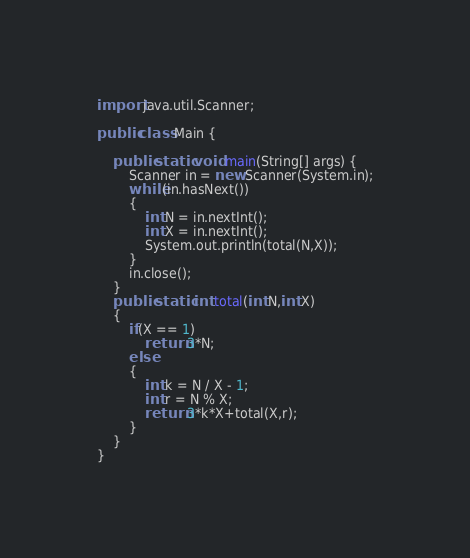<code> <loc_0><loc_0><loc_500><loc_500><_Java_>import java.util.Scanner;

public class Main {

	public static void main(String[] args) {
		Scanner in = new Scanner(System.in);
		while(in.hasNext())
		{
			int N = in.nextInt();
			int X = in.nextInt();
			System.out.println(total(N,X));
		}
		in.close();
	}
	public static int total(int N,int X)
	{
		if(X == 1)
			return 3*N;
		else
		{
			int k = N / X - 1;
			int r = N % X;
			return 3*k*X+total(X,r);
		}
	}
}</code> 